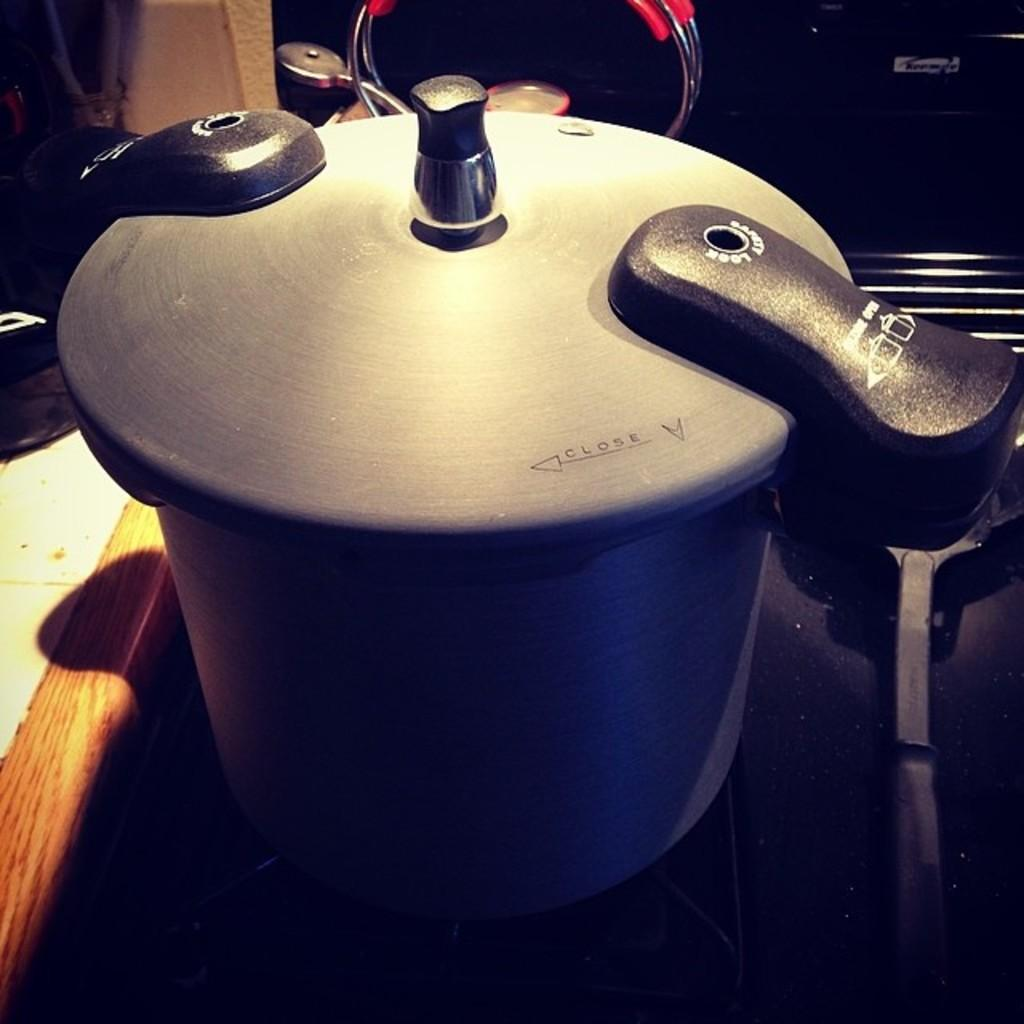<image>
Offer a succinct explanation of the picture presented. A silver and black cooking pot  that indicates  how to close it. 